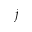<formula> <loc_0><loc_0><loc_500><loc_500>j</formula> 